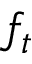<formula> <loc_0><loc_0><loc_500><loc_500>f _ { t }</formula> 